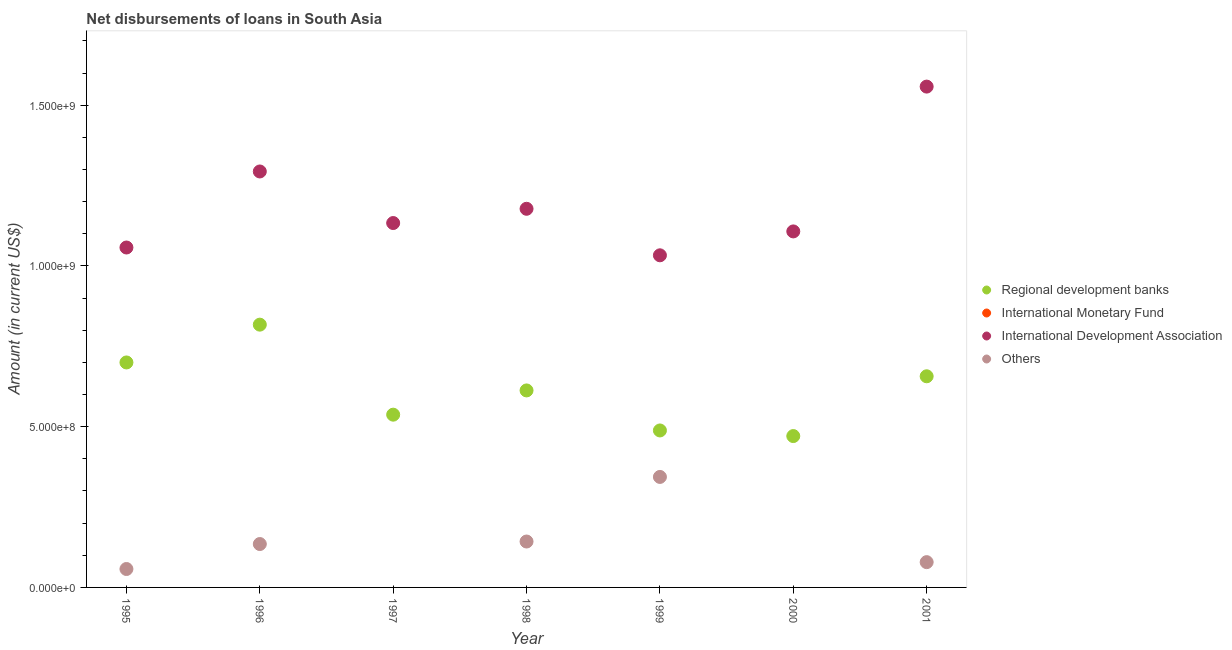How many different coloured dotlines are there?
Keep it short and to the point. 3. What is the amount of loan disimbursed by international development association in 2001?
Offer a terse response. 1.56e+09. Across all years, what is the maximum amount of loan disimbursed by international development association?
Provide a succinct answer. 1.56e+09. In which year was the amount of loan disimbursed by other organisations maximum?
Give a very brief answer. 1999. What is the difference between the amount of loan disimbursed by regional development banks in 1995 and that in 1997?
Ensure brevity in your answer.  1.62e+08. What is the difference between the amount of loan disimbursed by other organisations in 1999 and the amount of loan disimbursed by international monetary fund in 1995?
Provide a short and direct response. 3.44e+08. What is the average amount of loan disimbursed by other organisations per year?
Provide a short and direct response. 1.08e+08. In the year 1998, what is the difference between the amount of loan disimbursed by other organisations and amount of loan disimbursed by regional development banks?
Your response must be concise. -4.70e+08. What is the ratio of the amount of loan disimbursed by international development association in 1996 to that in 1998?
Make the answer very short. 1.1. Is the amount of loan disimbursed by regional development banks in 1997 less than that in 1999?
Your answer should be compact. No. What is the difference between the highest and the second highest amount of loan disimbursed by other organisations?
Offer a very short reply. 2.01e+08. What is the difference between the highest and the lowest amount of loan disimbursed by other organisations?
Your answer should be compact. 3.44e+08. In how many years, is the amount of loan disimbursed by international monetary fund greater than the average amount of loan disimbursed by international monetary fund taken over all years?
Your response must be concise. 0. Is it the case that in every year, the sum of the amount of loan disimbursed by regional development banks and amount of loan disimbursed by international development association is greater than the sum of amount of loan disimbursed by international monetary fund and amount of loan disimbursed by other organisations?
Offer a terse response. Yes. Is it the case that in every year, the sum of the amount of loan disimbursed by regional development banks and amount of loan disimbursed by international monetary fund is greater than the amount of loan disimbursed by international development association?
Your answer should be compact. No. Does the amount of loan disimbursed by international monetary fund monotonically increase over the years?
Offer a terse response. Yes. Is the amount of loan disimbursed by other organisations strictly greater than the amount of loan disimbursed by regional development banks over the years?
Make the answer very short. No. How many dotlines are there?
Your answer should be compact. 3. How many years are there in the graph?
Your response must be concise. 7. What is the difference between two consecutive major ticks on the Y-axis?
Offer a terse response. 5.00e+08. Are the values on the major ticks of Y-axis written in scientific E-notation?
Make the answer very short. Yes. Where does the legend appear in the graph?
Your response must be concise. Center right. How many legend labels are there?
Give a very brief answer. 4. How are the legend labels stacked?
Provide a succinct answer. Vertical. What is the title of the graph?
Your answer should be compact. Net disbursements of loans in South Asia. Does "Portugal" appear as one of the legend labels in the graph?
Your response must be concise. No. What is the label or title of the X-axis?
Ensure brevity in your answer.  Year. What is the Amount (in current US$) of Regional development banks in 1995?
Your answer should be compact. 7.00e+08. What is the Amount (in current US$) of International Development Association in 1995?
Your response must be concise. 1.06e+09. What is the Amount (in current US$) of Others in 1995?
Ensure brevity in your answer.  5.73e+07. What is the Amount (in current US$) in Regional development banks in 1996?
Provide a short and direct response. 8.17e+08. What is the Amount (in current US$) of International Monetary Fund in 1996?
Keep it short and to the point. 0. What is the Amount (in current US$) of International Development Association in 1996?
Make the answer very short. 1.29e+09. What is the Amount (in current US$) of Others in 1996?
Keep it short and to the point. 1.35e+08. What is the Amount (in current US$) in Regional development banks in 1997?
Your answer should be very brief. 5.37e+08. What is the Amount (in current US$) in International Development Association in 1997?
Your response must be concise. 1.13e+09. What is the Amount (in current US$) in Others in 1997?
Your response must be concise. 0. What is the Amount (in current US$) of Regional development banks in 1998?
Offer a terse response. 6.13e+08. What is the Amount (in current US$) of International Development Association in 1998?
Provide a succinct answer. 1.18e+09. What is the Amount (in current US$) of Others in 1998?
Ensure brevity in your answer.  1.43e+08. What is the Amount (in current US$) in Regional development banks in 1999?
Offer a terse response. 4.88e+08. What is the Amount (in current US$) in International Monetary Fund in 1999?
Provide a succinct answer. 0. What is the Amount (in current US$) of International Development Association in 1999?
Your response must be concise. 1.03e+09. What is the Amount (in current US$) of Others in 1999?
Your answer should be compact. 3.44e+08. What is the Amount (in current US$) of Regional development banks in 2000?
Your answer should be compact. 4.71e+08. What is the Amount (in current US$) of International Development Association in 2000?
Your answer should be compact. 1.11e+09. What is the Amount (in current US$) of Others in 2000?
Your response must be concise. 0. What is the Amount (in current US$) in Regional development banks in 2001?
Your response must be concise. 6.57e+08. What is the Amount (in current US$) of International Development Association in 2001?
Offer a very short reply. 1.56e+09. What is the Amount (in current US$) of Others in 2001?
Make the answer very short. 7.87e+07. Across all years, what is the maximum Amount (in current US$) in Regional development banks?
Ensure brevity in your answer.  8.17e+08. Across all years, what is the maximum Amount (in current US$) of International Development Association?
Ensure brevity in your answer.  1.56e+09. Across all years, what is the maximum Amount (in current US$) in Others?
Your answer should be compact. 3.44e+08. Across all years, what is the minimum Amount (in current US$) in Regional development banks?
Offer a very short reply. 4.71e+08. Across all years, what is the minimum Amount (in current US$) in International Development Association?
Make the answer very short. 1.03e+09. What is the total Amount (in current US$) of Regional development banks in the graph?
Make the answer very short. 4.28e+09. What is the total Amount (in current US$) of International Development Association in the graph?
Offer a terse response. 8.36e+09. What is the total Amount (in current US$) in Others in the graph?
Ensure brevity in your answer.  7.58e+08. What is the difference between the Amount (in current US$) in Regional development banks in 1995 and that in 1996?
Your answer should be very brief. -1.18e+08. What is the difference between the Amount (in current US$) in International Development Association in 1995 and that in 1996?
Give a very brief answer. -2.37e+08. What is the difference between the Amount (in current US$) of Others in 1995 and that in 1996?
Ensure brevity in your answer.  -7.77e+07. What is the difference between the Amount (in current US$) in Regional development banks in 1995 and that in 1997?
Give a very brief answer. 1.62e+08. What is the difference between the Amount (in current US$) of International Development Association in 1995 and that in 1997?
Your answer should be compact. -7.61e+07. What is the difference between the Amount (in current US$) of Regional development banks in 1995 and that in 1998?
Your response must be concise. 8.70e+07. What is the difference between the Amount (in current US$) of International Development Association in 1995 and that in 1998?
Your answer should be compact. -1.20e+08. What is the difference between the Amount (in current US$) of Others in 1995 and that in 1998?
Offer a terse response. -8.55e+07. What is the difference between the Amount (in current US$) in Regional development banks in 1995 and that in 1999?
Offer a very short reply. 2.12e+08. What is the difference between the Amount (in current US$) of International Development Association in 1995 and that in 1999?
Give a very brief answer. 2.43e+07. What is the difference between the Amount (in current US$) in Others in 1995 and that in 1999?
Your answer should be very brief. -2.86e+08. What is the difference between the Amount (in current US$) of Regional development banks in 1995 and that in 2000?
Make the answer very short. 2.29e+08. What is the difference between the Amount (in current US$) in International Development Association in 1995 and that in 2000?
Give a very brief answer. -5.01e+07. What is the difference between the Amount (in current US$) in Regional development banks in 1995 and that in 2001?
Offer a very short reply. 4.30e+07. What is the difference between the Amount (in current US$) of International Development Association in 1995 and that in 2001?
Offer a terse response. -5.01e+08. What is the difference between the Amount (in current US$) in Others in 1995 and that in 2001?
Make the answer very short. -2.14e+07. What is the difference between the Amount (in current US$) of Regional development banks in 1996 and that in 1997?
Provide a succinct answer. 2.80e+08. What is the difference between the Amount (in current US$) in International Development Association in 1996 and that in 1997?
Make the answer very short. 1.60e+08. What is the difference between the Amount (in current US$) in Regional development banks in 1996 and that in 1998?
Ensure brevity in your answer.  2.05e+08. What is the difference between the Amount (in current US$) of International Development Association in 1996 and that in 1998?
Offer a terse response. 1.16e+08. What is the difference between the Amount (in current US$) of Others in 1996 and that in 1998?
Give a very brief answer. -7.82e+06. What is the difference between the Amount (in current US$) in Regional development banks in 1996 and that in 1999?
Your answer should be compact. 3.29e+08. What is the difference between the Amount (in current US$) in International Development Association in 1996 and that in 1999?
Offer a terse response. 2.61e+08. What is the difference between the Amount (in current US$) in Others in 1996 and that in 1999?
Make the answer very short. -2.09e+08. What is the difference between the Amount (in current US$) in Regional development banks in 1996 and that in 2000?
Give a very brief answer. 3.47e+08. What is the difference between the Amount (in current US$) in International Development Association in 1996 and that in 2000?
Offer a terse response. 1.86e+08. What is the difference between the Amount (in current US$) in Regional development banks in 1996 and that in 2001?
Make the answer very short. 1.61e+08. What is the difference between the Amount (in current US$) in International Development Association in 1996 and that in 2001?
Your answer should be very brief. -2.64e+08. What is the difference between the Amount (in current US$) in Others in 1996 and that in 2001?
Provide a short and direct response. 5.63e+07. What is the difference between the Amount (in current US$) in Regional development banks in 1997 and that in 1998?
Your response must be concise. -7.54e+07. What is the difference between the Amount (in current US$) of International Development Association in 1997 and that in 1998?
Make the answer very short. -4.43e+07. What is the difference between the Amount (in current US$) in Regional development banks in 1997 and that in 1999?
Provide a short and direct response. 4.91e+07. What is the difference between the Amount (in current US$) in International Development Association in 1997 and that in 1999?
Give a very brief answer. 1.00e+08. What is the difference between the Amount (in current US$) in Regional development banks in 1997 and that in 2000?
Offer a very short reply. 6.66e+07. What is the difference between the Amount (in current US$) in International Development Association in 1997 and that in 2000?
Make the answer very short. 2.61e+07. What is the difference between the Amount (in current US$) of Regional development banks in 1997 and that in 2001?
Your answer should be very brief. -1.19e+08. What is the difference between the Amount (in current US$) of International Development Association in 1997 and that in 2001?
Provide a succinct answer. -4.24e+08. What is the difference between the Amount (in current US$) in Regional development banks in 1998 and that in 1999?
Provide a succinct answer. 1.25e+08. What is the difference between the Amount (in current US$) of International Development Association in 1998 and that in 1999?
Keep it short and to the point. 1.45e+08. What is the difference between the Amount (in current US$) in Others in 1998 and that in 1999?
Your response must be concise. -2.01e+08. What is the difference between the Amount (in current US$) of Regional development banks in 1998 and that in 2000?
Provide a succinct answer. 1.42e+08. What is the difference between the Amount (in current US$) in International Development Association in 1998 and that in 2000?
Your answer should be very brief. 7.04e+07. What is the difference between the Amount (in current US$) in Regional development banks in 1998 and that in 2001?
Provide a short and direct response. -4.40e+07. What is the difference between the Amount (in current US$) of International Development Association in 1998 and that in 2001?
Your answer should be compact. -3.80e+08. What is the difference between the Amount (in current US$) of Others in 1998 and that in 2001?
Your answer should be compact. 6.42e+07. What is the difference between the Amount (in current US$) of Regional development banks in 1999 and that in 2000?
Ensure brevity in your answer.  1.75e+07. What is the difference between the Amount (in current US$) of International Development Association in 1999 and that in 2000?
Give a very brief answer. -7.43e+07. What is the difference between the Amount (in current US$) of Regional development banks in 1999 and that in 2001?
Offer a very short reply. -1.69e+08. What is the difference between the Amount (in current US$) of International Development Association in 1999 and that in 2001?
Your answer should be compact. -5.25e+08. What is the difference between the Amount (in current US$) of Others in 1999 and that in 2001?
Offer a terse response. 2.65e+08. What is the difference between the Amount (in current US$) of Regional development banks in 2000 and that in 2001?
Your answer should be compact. -1.86e+08. What is the difference between the Amount (in current US$) in International Development Association in 2000 and that in 2001?
Make the answer very short. -4.50e+08. What is the difference between the Amount (in current US$) in Regional development banks in 1995 and the Amount (in current US$) in International Development Association in 1996?
Your answer should be compact. -5.94e+08. What is the difference between the Amount (in current US$) of Regional development banks in 1995 and the Amount (in current US$) of Others in 1996?
Ensure brevity in your answer.  5.65e+08. What is the difference between the Amount (in current US$) in International Development Association in 1995 and the Amount (in current US$) in Others in 1996?
Keep it short and to the point. 9.22e+08. What is the difference between the Amount (in current US$) in Regional development banks in 1995 and the Amount (in current US$) in International Development Association in 1997?
Your answer should be very brief. -4.34e+08. What is the difference between the Amount (in current US$) of Regional development banks in 1995 and the Amount (in current US$) of International Development Association in 1998?
Provide a short and direct response. -4.78e+08. What is the difference between the Amount (in current US$) of Regional development banks in 1995 and the Amount (in current US$) of Others in 1998?
Keep it short and to the point. 5.57e+08. What is the difference between the Amount (in current US$) of International Development Association in 1995 and the Amount (in current US$) of Others in 1998?
Offer a very short reply. 9.15e+08. What is the difference between the Amount (in current US$) in Regional development banks in 1995 and the Amount (in current US$) in International Development Association in 1999?
Provide a short and direct response. -3.33e+08. What is the difference between the Amount (in current US$) of Regional development banks in 1995 and the Amount (in current US$) of Others in 1999?
Your answer should be very brief. 3.56e+08. What is the difference between the Amount (in current US$) in International Development Association in 1995 and the Amount (in current US$) in Others in 1999?
Your response must be concise. 7.14e+08. What is the difference between the Amount (in current US$) in Regional development banks in 1995 and the Amount (in current US$) in International Development Association in 2000?
Give a very brief answer. -4.08e+08. What is the difference between the Amount (in current US$) in Regional development banks in 1995 and the Amount (in current US$) in International Development Association in 2001?
Ensure brevity in your answer.  -8.58e+08. What is the difference between the Amount (in current US$) in Regional development banks in 1995 and the Amount (in current US$) in Others in 2001?
Provide a short and direct response. 6.21e+08. What is the difference between the Amount (in current US$) of International Development Association in 1995 and the Amount (in current US$) of Others in 2001?
Provide a succinct answer. 9.79e+08. What is the difference between the Amount (in current US$) of Regional development banks in 1996 and the Amount (in current US$) of International Development Association in 1997?
Your answer should be very brief. -3.16e+08. What is the difference between the Amount (in current US$) of Regional development banks in 1996 and the Amount (in current US$) of International Development Association in 1998?
Keep it short and to the point. -3.60e+08. What is the difference between the Amount (in current US$) in Regional development banks in 1996 and the Amount (in current US$) in Others in 1998?
Keep it short and to the point. 6.75e+08. What is the difference between the Amount (in current US$) in International Development Association in 1996 and the Amount (in current US$) in Others in 1998?
Provide a succinct answer. 1.15e+09. What is the difference between the Amount (in current US$) in Regional development banks in 1996 and the Amount (in current US$) in International Development Association in 1999?
Make the answer very short. -2.16e+08. What is the difference between the Amount (in current US$) of Regional development banks in 1996 and the Amount (in current US$) of Others in 1999?
Offer a very short reply. 4.74e+08. What is the difference between the Amount (in current US$) in International Development Association in 1996 and the Amount (in current US$) in Others in 1999?
Offer a very short reply. 9.50e+08. What is the difference between the Amount (in current US$) in Regional development banks in 1996 and the Amount (in current US$) in International Development Association in 2000?
Provide a short and direct response. -2.90e+08. What is the difference between the Amount (in current US$) in Regional development banks in 1996 and the Amount (in current US$) in International Development Association in 2001?
Provide a succinct answer. -7.41e+08. What is the difference between the Amount (in current US$) in Regional development banks in 1996 and the Amount (in current US$) in Others in 2001?
Provide a succinct answer. 7.39e+08. What is the difference between the Amount (in current US$) of International Development Association in 1996 and the Amount (in current US$) of Others in 2001?
Give a very brief answer. 1.22e+09. What is the difference between the Amount (in current US$) of Regional development banks in 1997 and the Amount (in current US$) of International Development Association in 1998?
Provide a short and direct response. -6.40e+08. What is the difference between the Amount (in current US$) of Regional development banks in 1997 and the Amount (in current US$) of Others in 1998?
Provide a short and direct response. 3.95e+08. What is the difference between the Amount (in current US$) of International Development Association in 1997 and the Amount (in current US$) of Others in 1998?
Keep it short and to the point. 9.91e+08. What is the difference between the Amount (in current US$) of Regional development banks in 1997 and the Amount (in current US$) of International Development Association in 1999?
Keep it short and to the point. -4.96e+08. What is the difference between the Amount (in current US$) in Regional development banks in 1997 and the Amount (in current US$) in Others in 1999?
Offer a very short reply. 1.94e+08. What is the difference between the Amount (in current US$) in International Development Association in 1997 and the Amount (in current US$) in Others in 1999?
Ensure brevity in your answer.  7.90e+08. What is the difference between the Amount (in current US$) of Regional development banks in 1997 and the Amount (in current US$) of International Development Association in 2000?
Ensure brevity in your answer.  -5.70e+08. What is the difference between the Amount (in current US$) in Regional development banks in 1997 and the Amount (in current US$) in International Development Association in 2001?
Keep it short and to the point. -1.02e+09. What is the difference between the Amount (in current US$) in Regional development banks in 1997 and the Amount (in current US$) in Others in 2001?
Offer a very short reply. 4.59e+08. What is the difference between the Amount (in current US$) in International Development Association in 1997 and the Amount (in current US$) in Others in 2001?
Give a very brief answer. 1.05e+09. What is the difference between the Amount (in current US$) of Regional development banks in 1998 and the Amount (in current US$) of International Development Association in 1999?
Offer a very short reply. -4.20e+08. What is the difference between the Amount (in current US$) in Regional development banks in 1998 and the Amount (in current US$) in Others in 1999?
Provide a short and direct response. 2.69e+08. What is the difference between the Amount (in current US$) in International Development Association in 1998 and the Amount (in current US$) in Others in 1999?
Your response must be concise. 8.34e+08. What is the difference between the Amount (in current US$) in Regional development banks in 1998 and the Amount (in current US$) in International Development Association in 2000?
Your response must be concise. -4.95e+08. What is the difference between the Amount (in current US$) of Regional development banks in 1998 and the Amount (in current US$) of International Development Association in 2001?
Offer a very short reply. -9.45e+08. What is the difference between the Amount (in current US$) in Regional development banks in 1998 and the Amount (in current US$) in Others in 2001?
Your answer should be very brief. 5.34e+08. What is the difference between the Amount (in current US$) in International Development Association in 1998 and the Amount (in current US$) in Others in 2001?
Your answer should be compact. 1.10e+09. What is the difference between the Amount (in current US$) in Regional development banks in 1999 and the Amount (in current US$) in International Development Association in 2000?
Make the answer very short. -6.19e+08. What is the difference between the Amount (in current US$) of Regional development banks in 1999 and the Amount (in current US$) of International Development Association in 2001?
Provide a short and direct response. -1.07e+09. What is the difference between the Amount (in current US$) in Regional development banks in 1999 and the Amount (in current US$) in Others in 2001?
Offer a very short reply. 4.10e+08. What is the difference between the Amount (in current US$) of International Development Association in 1999 and the Amount (in current US$) of Others in 2001?
Offer a very short reply. 9.55e+08. What is the difference between the Amount (in current US$) of Regional development banks in 2000 and the Amount (in current US$) of International Development Association in 2001?
Offer a very short reply. -1.09e+09. What is the difference between the Amount (in current US$) in Regional development banks in 2000 and the Amount (in current US$) in Others in 2001?
Provide a succinct answer. 3.92e+08. What is the difference between the Amount (in current US$) in International Development Association in 2000 and the Amount (in current US$) in Others in 2001?
Give a very brief answer. 1.03e+09. What is the average Amount (in current US$) in Regional development banks per year?
Your answer should be compact. 6.12e+08. What is the average Amount (in current US$) in International Monetary Fund per year?
Offer a very short reply. 0. What is the average Amount (in current US$) of International Development Association per year?
Your answer should be very brief. 1.19e+09. What is the average Amount (in current US$) in Others per year?
Offer a terse response. 1.08e+08. In the year 1995, what is the difference between the Amount (in current US$) of Regional development banks and Amount (in current US$) of International Development Association?
Provide a succinct answer. -3.58e+08. In the year 1995, what is the difference between the Amount (in current US$) of Regional development banks and Amount (in current US$) of Others?
Provide a short and direct response. 6.43e+08. In the year 1995, what is the difference between the Amount (in current US$) in International Development Association and Amount (in current US$) in Others?
Ensure brevity in your answer.  1.00e+09. In the year 1996, what is the difference between the Amount (in current US$) in Regional development banks and Amount (in current US$) in International Development Association?
Ensure brevity in your answer.  -4.77e+08. In the year 1996, what is the difference between the Amount (in current US$) of Regional development banks and Amount (in current US$) of Others?
Make the answer very short. 6.82e+08. In the year 1996, what is the difference between the Amount (in current US$) in International Development Association and Amount (in current US$) in Others?
Offer a very short reply. 1.16e+09. In the year 1997, what is the difference between the Amount (in current US$) of Regional development banks and Amount (in current US$) of International Development Association?
Offer a terse response. -5.96e+08. In the year 1998, what is the difference between the Amount (in current US$) in Regional development banks and Amount (in current US$) in International Development Association?
Your answer should be very brief. -5.65e+08. In the year 1998, what is the difference between the Amount (in current US$) in Regional development banks and Amount (in current US$) in Others?
Your answer should be very brief. 4.70e+08. In the year 1998, what is the difference between the Amount (in current US$) of International Development Association and Amount (in current US$) of Others?
Give a very brief answer. 1.04e+09. In the year 1999, what is the difference between the Amount (in current US$) of Regional development banks and Amount (in current US$) of International Development Association?
Your answer should be compact. -5.45e+08. In the year 1999, what is the difference between the Amount (in current US$) of Regional development banks and Amount (in current US$) of Others?
Your answer should be very brief. 1.45e+08. In the year 1999, what is the difference between the Amount (in current US$) of International Development Association and Amount (in current US$) of Others?
Give a very brief answer. 6.89e+08. In the year 2000, what is the difference between the Amount (in current US$) of Regional development banks and Amount (in current US$) of International Development Association?
Give a very brief answer. -6.37e+08. In the year 2001, what is the difference between the Amount (in current US$) of Regional development banks and Amount (in current US$) of International Development Association?
Provide a succinct answer. -9.01e+08. In the year 2001, what is the difference between the Amount (in current US$) of Regional development banks and Amount (in current US$) of Others?
Ensure brevity in your answer.  5.78e+08. In the year 2001, what is the difference between the Amount (in current US$) in International Development Association and Amount (in current US$) in Others?
Your answer should be compact. 1.48e+09. What is the ratio of the Amount (in current US$) in Regional development banks in 1995 to that in 1996?
Offer a very short reply. 0.86. What is the ratio of the Amount (in current US$) in International Development Association in 1995 to that in 1996?
Your response must be concise. 0.82. What is the ratio of the Amount (in current US$) of Others in 1995 to that in 1996?
Your answer should be compact. 0.42. What is the ratio of the Amount (in current US$) in Regional development banks in 1995 to that in 1997?
Offer a terse response. 1.3. What is the ratio of the Amount (in current US$) in International Development Association in 1995 to that in 1997?
Provide a succinct answer. 0.93. What is the ratio of the Amount (in current US$) of Regional development banks in 1995 to that in 1998?
Ensure brevity in your answer.  1.14. What is the ratio of the Amount (in current US$) in International Development Association in 1995 to that in 1998?
Your response must be concise. 0.9. What is the ratio of the Amount (in current US$) of Others in 1995 to that in 1998?
Ensure brevity in your answer.  0.4. What is the ratio of the Amount (in current US$) of Regional development banks in 1995 to that in 1999?
Provide a short and direct response. 1.43. What is the ratio of the Amount (in current US$) in International Development Association in 1995 to that in 1999?
Keep it short and to the point. 1.02. What is the ratio of the Amount (in current US$) in Regional development banks in 1995 to that in 2000?
Ensure brevity in your answer.  1.49. What is the ratio of the Amount (in current US$) in International Development Association in 1995 to that in 2000?
Your response must be concise. 0.95. What is the ratio of the Amount (in current US$) of Regional development banks in 1995 to that in 2001?
Ensure brevity in your answer.  1.07. What is the ratio of the Amount (in current US$) in International Development Association in 1995 to that in 2001?
Your response must be concise. 0.68. What is the ratio of the Amount (in current US$) of Others in 1995 to that in 2001?
Offer a terse response. 0.73. What is the ratio of the Amount (in current US$) of Regional development banks in 1996 to that in 1997?
Offer a very short reply. 1.52. What is the ratio of the Amount (in current US$) of International Development Association in 1996 to that in 1997?
Make the answer very short. 1.14. What is the ratio of the Amount (in current US$) in Regional development banks in 1996 to that in 1998?
Provide a succinct answer. 1.33. What is the ratio of the Amount (in current US$) of International Development Association in 1996 to that in 1998?
Make the answer very short. 1.1. What is the ratio of the Amount (in current US$) in Others in 1996 to that in 1998?
Make the answer very short. 0.95. What is the ratio of the Amount (in current US$) of Regional development banks in 1996 to that in 1999?
Offer a very short reply. 1.67. What is the ratio of the Amount (in current US$) in International Development Association in 1996 to that in 1999?
Your response must be concise. 1.25. What is the ratio of the Amount (in current US$) in Others in 1996 to that in 1999?
Give a very brief answer. 0.39. What is the ratio of the Amount (in current US$) in Regional development banks in 1996 to that in 2000?
Your answer should be compact. 1.74. What is the ratio of the Amount (in current US$) in International Development Association in 1996 to that in 2000?
Provide a short and direct response. 1.17. What is the ratio of the Amount (in current US$) of Regional development banks in 1996 to that in 2001?
Provide a short and direct response. 1.24. What is the ratio of the Amount (in current US$) of International Development Association in 1996 to that in 2001?
Give a very brief answer. 0.83. What is the ratio of the Amount (in current US$) in Others in 1996 to that in 2001?
Offer a very short reply. 1.72. What is the ratio of the Amount (in current US$) in Regional development banks in 1997 to that in 1998?
Make the answer very short. 0.88. What is the ratio of the Amount (in current US$) in International Development Association in 1997 to that in 1998?
Keep it short and to the point. 0.96. What is the ratio of the Amount (in current US$) of Regional development banks in 1997 to that in 1999?
Give a very brief answer. 1.1. What is the ratio of the Amount (in current US$) of International Development Association in 1997 to that in 1999?
Give a very brief answer. 1.1. What is the ratio of the Amount (in current US$) in Regional development banks in 1997 to that in 2000?
Provide a short and direct response. 1.14. What is the ratio of the Amount (in current US$) in International Development Association in 1997 to that in 2000?
Ensure brevity in your answer.  1.02. What is the ratio of the Amount (in current US$) of Regional development banks in 1997 to that in 2001?
Your response must be concise. 0.82. What is the ratio of the Amount (in current US$) of International Development Association in 1997 to that in 2001?
Give a very brief answer. 0.73. What is the ratio of the Amount (in current US$) of Regional development banks in 1998 to that in 1999?
Your answer should be very brief. 1.25. What is the ratio of the Amount (in current US$) of International Development Association in 1998 to that in 1999?
Keep it short and to the point. 1.14. What is the ratio of the Amount (in current US$) in Others in 1998 to that in 1999?
Provide a short and direct response. 0.42. What is the ratio of the Amount (in current US$) in Regional development banks in 1998 to that in 2000?
Your answer should be compact. 1.3. What is the ratio of the Amount (in current US$) in International Development Association in 1998 to that in 2000?
Keep it short and to the point. 1.06. What is the ratio of the Amount (in current US$) in Regional development banks in 1998 to that in 2001?
Your answer should be compact. 0.93. What is the ratio of the Amount (in current US$) of International Development Association in 1998 to that in 2001?
Offer a very short reply. 0.76. What is the ratio of the Amount (in current US$) in Others in 1998 to that in 2001?
Offer a terse response. 1.82. What is the ratio of the Amount (in current US$) in Regional development banks in 1999 to that in 2000?
Keep it short and to the point. 1.04. What is the ratio of the Amount (in current US$) of International Development Association in 1999 to that in 2000?
Give a very brief answer. 0.93. What is the ratio of the Amount (in current US$) in Regional development banks in 1999 to that in 2001?
Your answer should be compact. 0.74. What is the ratio of the Amount (in current US$) in International Development Association in 1999 to that in 2001?
Keep it short and to the point. 0.66. What is the ratio of the Amount (in current US$) of Others in 1999 to that in 2001?
Make the answer very short. 4.37. What is the ratio of the Amount (in current US$) in Regional development banks in 2000 to that in 2001?
Offer a terse response. 0.72. What is the ratio of the Amount (in current US$) in International Development Association in 2000 to that in 2001?
Offer a terse response. 0.71. What is the difference between the highest and the second highest Amount (in current US$) of Regional development banks?
Offer a terse response. 1.18e+08. What is the difference between the highest and the second highest Amount (in current US$) in International Development Association?
Your answer should be compact. 2.64e+08. What is the difference between the highest and the second highest Amount (in current US$) of Others?
Keep it short and to the point. 2.01e+08. What is the difference between the highest and the lowest Amount (in current US$) of Regional development banks?
Give a very brief answer. 3.47e+08. What is the difference between the highest and the lowest Amount (in current US$) in International Development Association?
Offer a very short reply. 5.25e+08. What is the difference between the highest and the lowest Amount (in current US$) in Others?
Ensure brevity in your answer.  3.44e+08. 